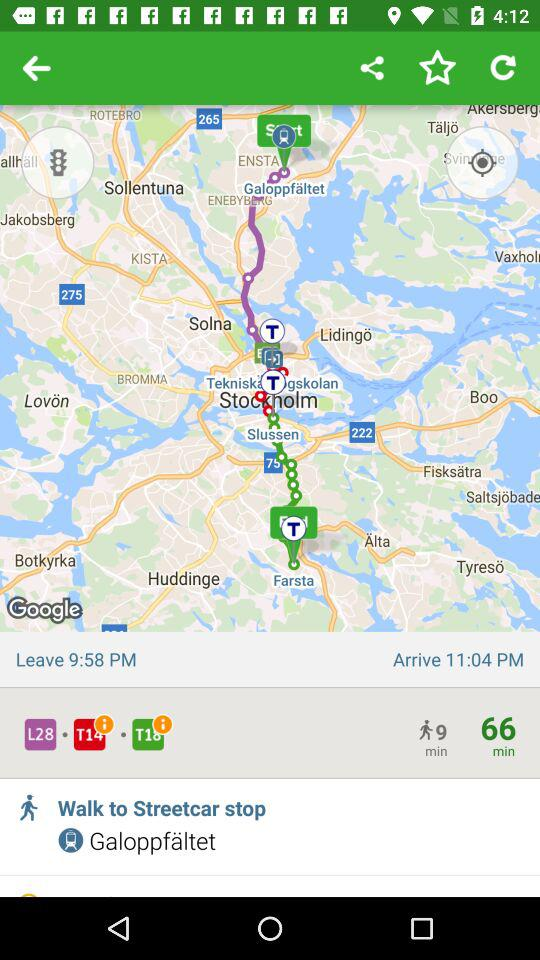What's the departure time? The departure time is 9:58 p.m. 